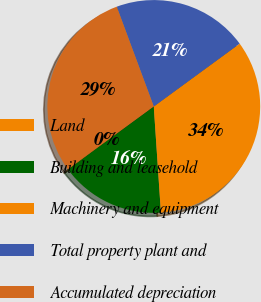Convert chart. <chart><loc_0><loc_0><loc_500><loc_500><pie_chart><fcel>Land<fcel>Building and leasehold<fcel>Machinery and equipment<fcel>Total property plant and<fcel>Accumulated depreciation<nl><fcel>0.09%<fcel>15.97%<fcel>33.98%<fcel>20.6%<fcel>29.35%<nl></chart> 